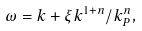Convert formula to latex. <formula><loc_0><loc_0><loc_500><loc_500>\omega = k + \xi k ^ { 1 + n } / k _ { P } ^ { n } ,</formula> 